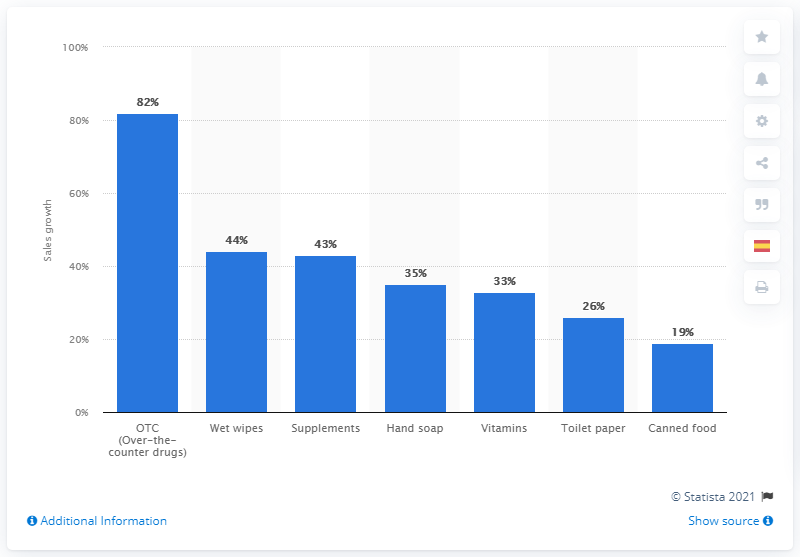Mention a couple of crucial points in this snapshot. The sales of over-the-counter drugs in Colombia increased by 82% in February 2020. February 2020 saw a significant increase in the sales of over-the-counter drugs in Colombia, with a growth of 82%. 